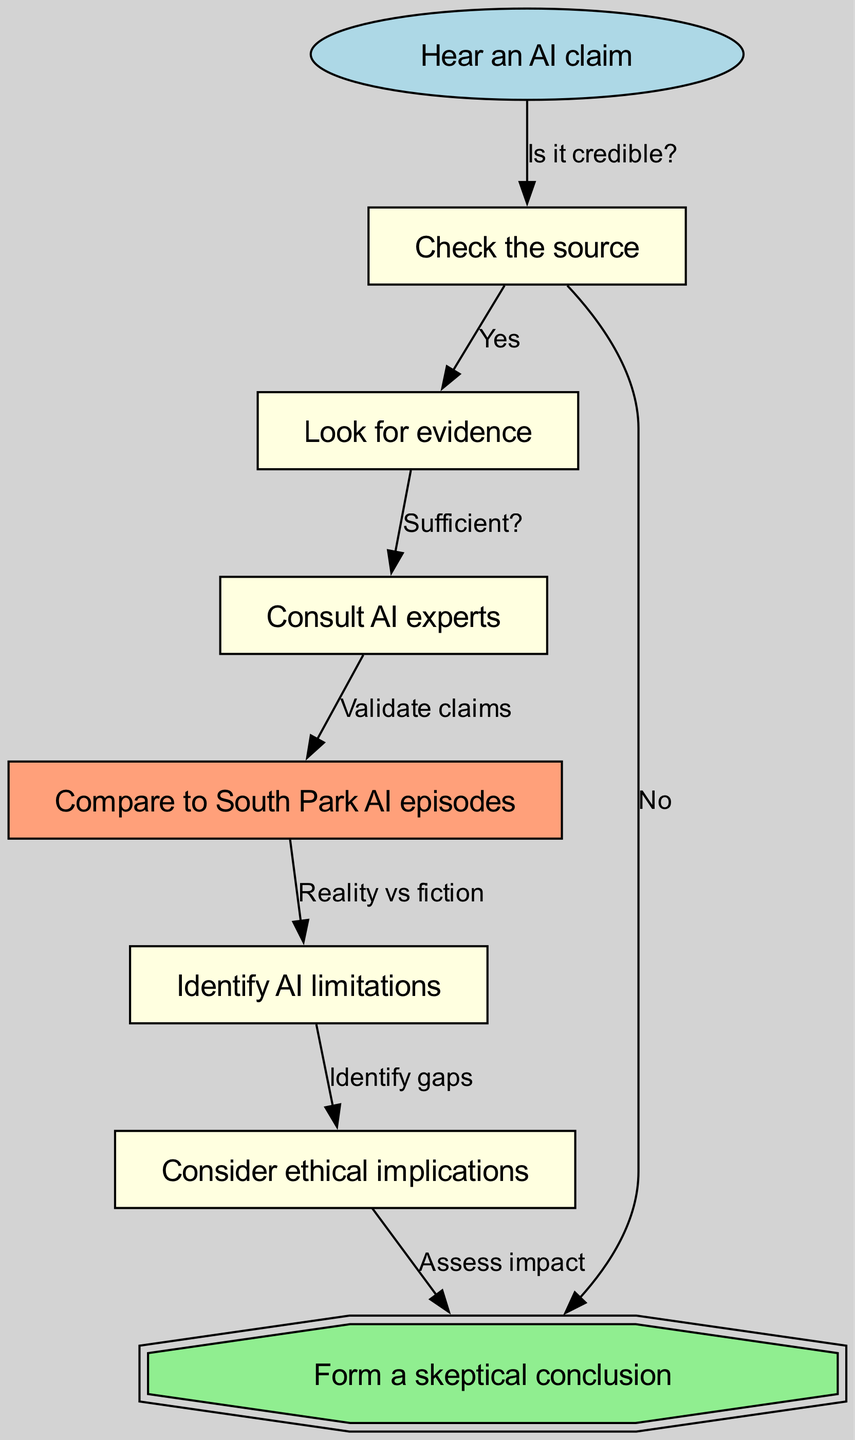What is the first node in the flow chart? The first node is "Hear an AI claim," which is indicated as the starting point of the flow chart.
Answer: Hear an AI claim How many nodes are in the flow chart? By counting all the nodes listed in the flow chart, we identify a total of 7 nodes, including the starting point.
Answer: 7 What is the last node in the flow chart? The last node is "Form a skeptical conclusion," which represents the final step in the evaluation process.
Answer: Form a skeptical conclusion What comes after "Check the source" if it is credible? If "Check the source" confirms credibility, the next step is "Look for evidence," as indicated by the edge connecting these two nodes.
Answer: Look for evidence What do you do after "Look for evidence" if it is sufficient? If the evidence deemed sufficient, the next step requires you to "Consult AI experts" for validation of the claims made.
Answer: Consult AI experts In the flow chart, which node relates to assessing the impact of AI? The node that relates to assessing the impact of AI is "Consider ethical implications," as it specifically addresses the consequences of AI on ethics.
Answer: Consider ethical implications What node connects "Compare to South Park AI episodes"? The node that connects to "Compare to South Park AI episodes" is "Consult AI experts," showing that validation from experts leads into comparison with cultural references.
Answer: Consult AI experts What does the "Identify AI limitations" node connect to? The "Identify AI limitations" node connects to "Consider ethical implications," indicating that understanding limitations informs ethical considerations.
Answer: Consider ethical implications How does the flow chart connect fictional portrayals of AI? The flow chart uses "Compare to South Park AI episodes" to examine the difference between fiction and the reality of AI, illustrating a critical analysis approach.
Answer: Compare to South Park AI episodes 